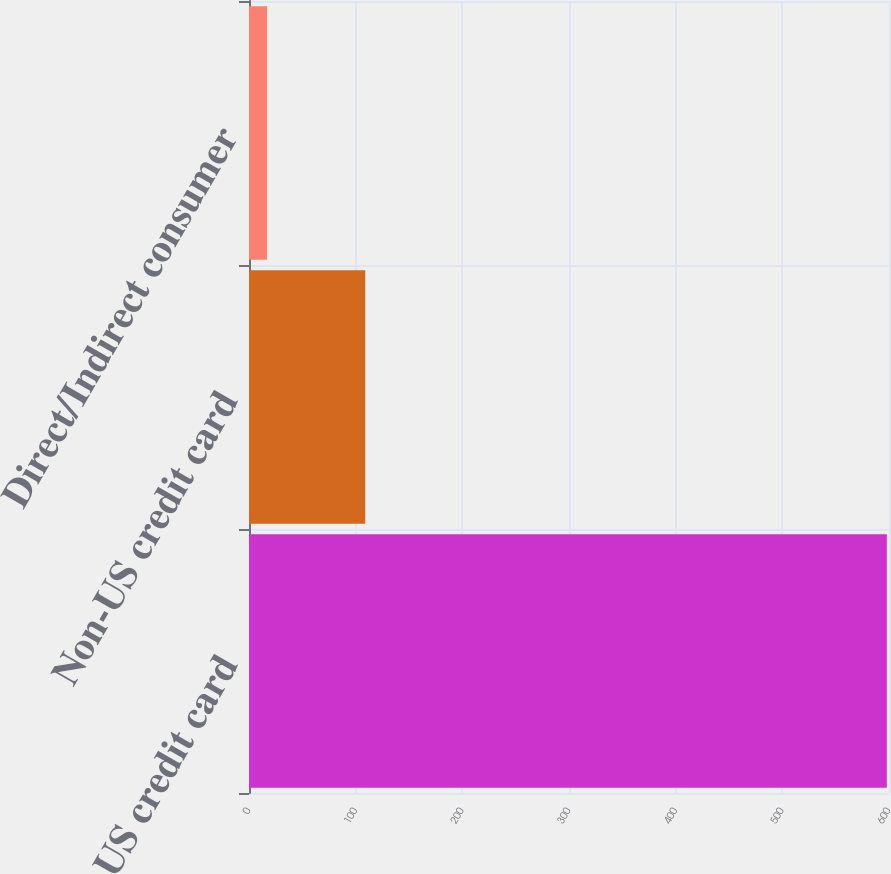<chart> <loc_0><loc_0><loc_500><loc_500><bar_chart><fcel>US credit card<fcel>Non-US credit card<fcel>Direct/Indirect consumer<nl><fcel>598<fcel>109<fcel>17<nl></chart> 